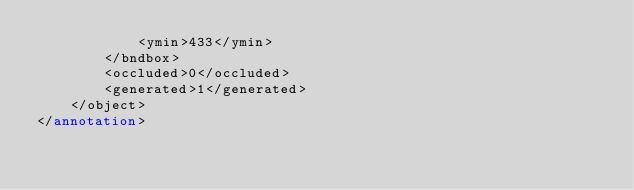<code> <loc_0><loc_0><loc_500><loc_500><_XML_>			<ymin>433</ymin>
		</bndbox>
		<occluded>0</occluded>
		<generated>1</generated>
	</object>
</annotation>
</code> 